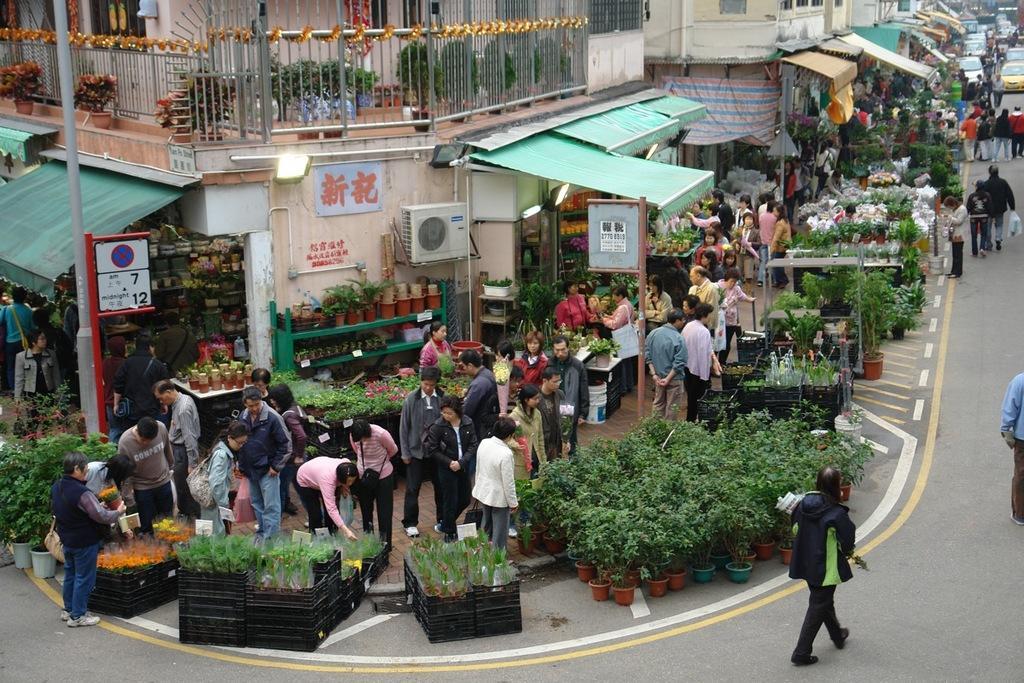Can you describe this image briefly? In this picture there are people in the center of the image and there are buildings at the top side of the image, there are cars in the top right side of the image, there is a pole on the left side of the image and there are stalls in the center of the image, there are plants pots in front of the stalls. 